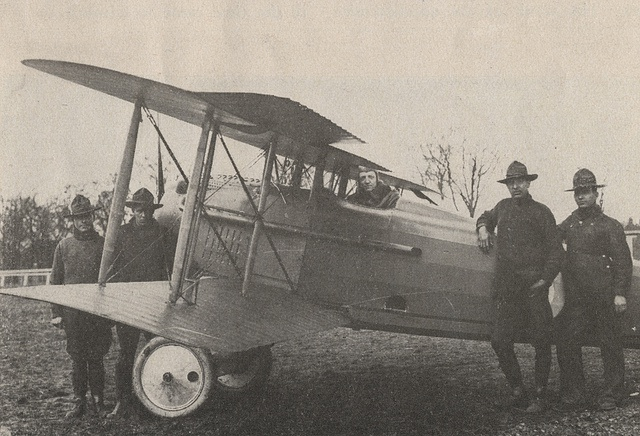Describe the objects in this image and their specific colors. I can see airplane in tan, gray, darkgray, and lightgray tones, people in tan, gray, and black tones, people in tan, gray, and black tones, people in tan, gray, and black tones, and people in tan, gray, and black tones in this image. 